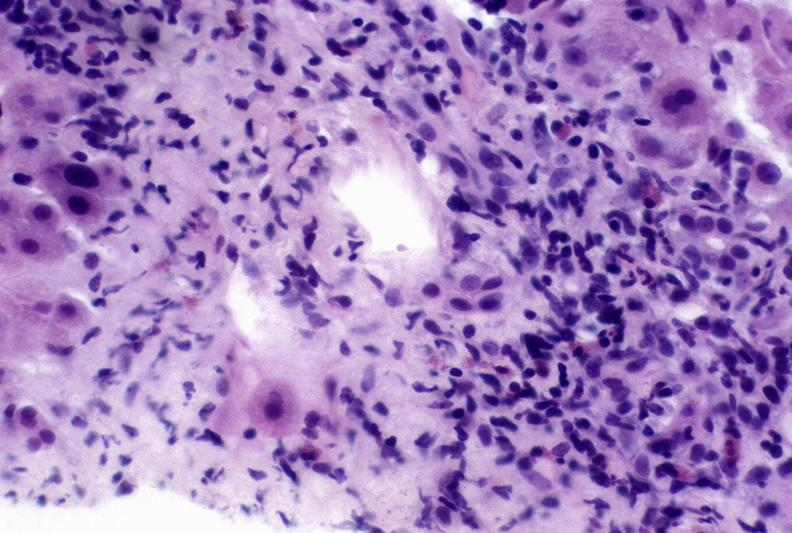does this image show autoimmune hepatitis?
Answer the question using a single word or phrase. Yes 